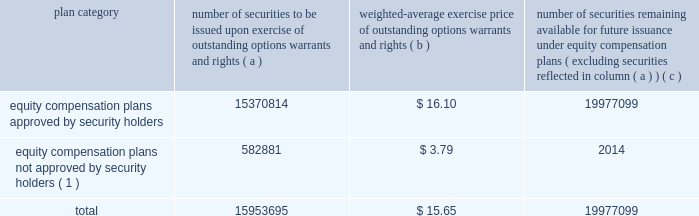Part iii item 10 .
Directors , and executive officers and corporate governance .
Pursuant to section 406 of the sarbanes-oxley act of 2002 , we have adopted a code of ethics for senior financial officers that applies to our principal executive officer and principal financial officer , principal accounting officer and controller , and other persons performing similar functions .
Our code of ethics for senior financial officers is publicly available on our website at www.hologic.com .
We intend to satisfy the disclosure requirement under item 5.05 of current report on form 8-k regarding an amendment to , or waiver from , a provision of this code by posting such information on our website , at the address specified above .
The additional information required by this item is incorporated by reference to our definitive proxy statement for our annual meeting of stockholders to be filed with the securities and exchange commission within 120 days after the close of our fiscal year .
Item 11 .
Executive compensation .
The information required by this item is incorporated by reference to our definitive proxy statement for our annual meeting of stockholders to be filed with the securities and exchange commission within 120 days after the close of our fiscal year .
Item 12 .
Security ownership of certain beneficial owners and management and related stockholder matters .
We maintain a number of equity compensation plans for employees , officers , directors and others whose efforts contribute to our success .
The table below sets forth certain information as of the end of our fiscal year ended september 27 , 2008 regarding the shares of our common stock available for grant or granted under stock option plans and equity incentives that ( i ) were approved by our stockholders , and ( ii ) were not approved by our stockholders .
The number of securities and the exercise price of the outstanding securities have been adjusted to reflect our two-for-one stock splits effected on november 30 , 2005 and april 2 , 2008 .
Equity compensation plan information plan category number of securities to be issued upon exercise of outstanding options , warrants and rights weighted-average exercise price of outstanding options , warrants and rights number of securities remaining available for future issuance under equity compensation plans ( excluding securities reflected in column ( a ) ) equity compensation plans approved by security holders .
15370814 $ 16.10 19977099 equity compensation plans not approved by security holders ( 1 ) .
582881 $ 3.79 2014 .
( 1 ) includes the following plans : 1997 employee equity incentive plan and 2000 acquisition equity incentive plan .
A description of each of these plans is as follows : 1997 employee equity incentive plan .
The purposes of the 1997 employee equity incentive plan ( the 201c1997 plan 201d ) , adopted by the board of directors in may 1997 , are to attract and retain key employees , consultants and advisors , to provide an incentive for them to assist us in achieving long-range performance goals , and to enable such person to participate in our long-term growth .
In general , under the 1997 plan , all employees .
What portion of the total number of issued securities is approved by security holders? 
Computations: (15370814 / 15953695)
Answer: 0.96346. 